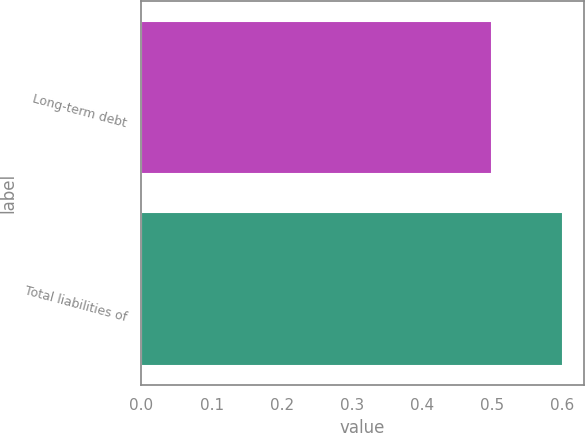Convert chart. <chart><loc_0><loc_0><loc_500><loc_500><bar_chart><fcel>Long-term debt<fcel>Total liabilities of<nl><fcel>0.5<fcel>0.6<nl></chart> 